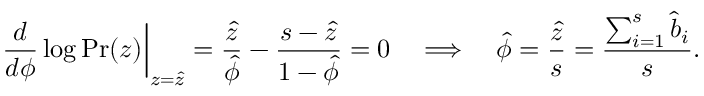<formula> <loc_0><loc_0><loc_500><loc_500>\frac { d } { d \phi } \log P r ( z ) \right | _ { z = \hat { z } } = \frac { \hat { z } } { \hat { \phi } } - \frac { s - \hat { z } } { 1 - \hat { \phi } } = 0 \quad \Longrightarrow \quad \hat { \phi } = \frac { \hat { z } } { s } = \frac { \sum _ { i = 1 } ^ { s } \hat { b } _ { i } } { s } .</formula> 